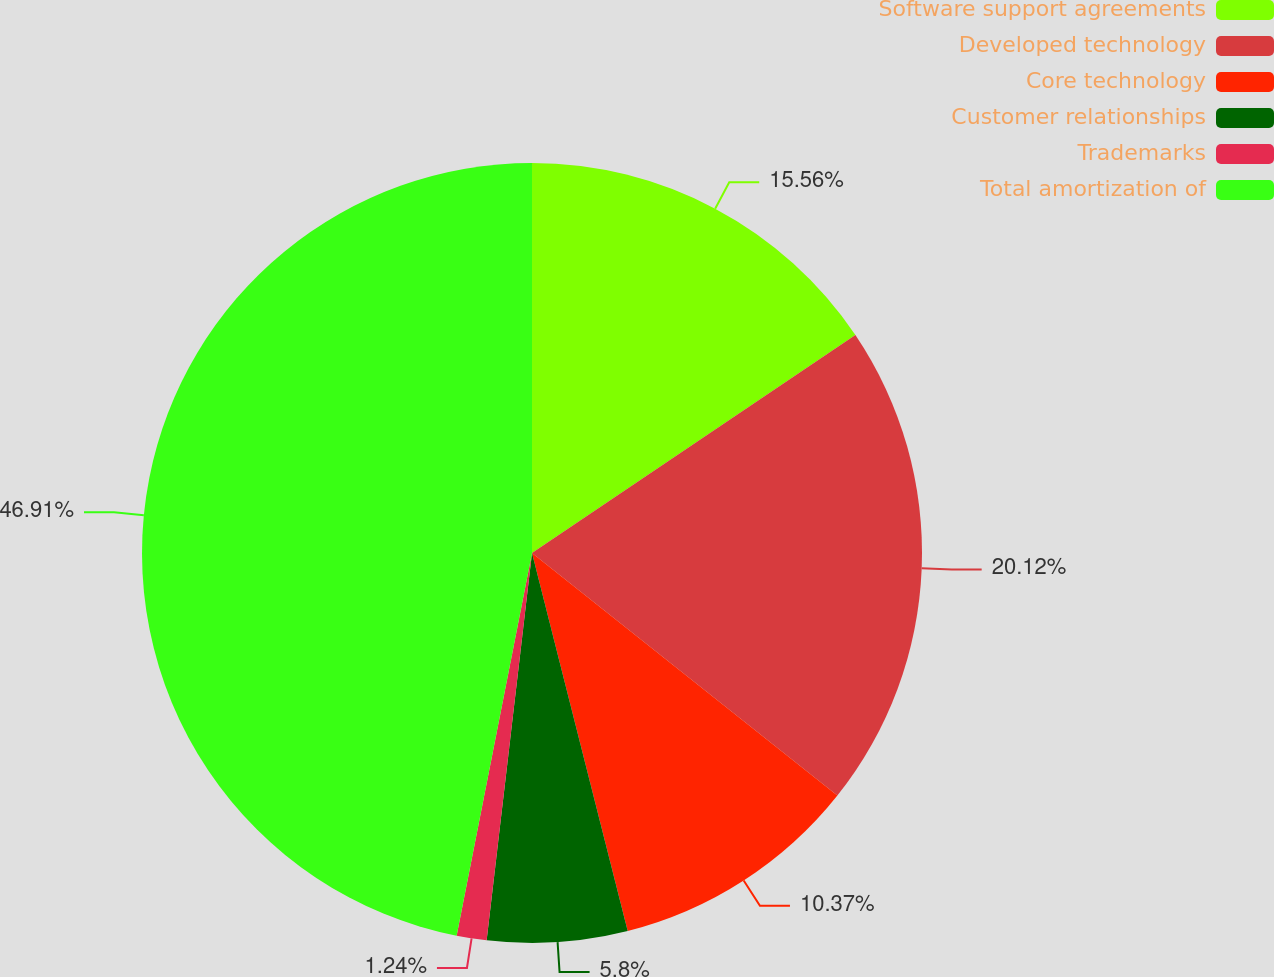Convert chart. <chart><loc_0><loc_0><loc_500><loc_500><pie_chart><fcel>Software support agreements<fcel>Developed technology<fcel>Core technology<fcel>Customer relationships<fcel>Trademarks<fcel>Total amortization of<nl><fcel>15.56%<fcel>20.12%<fcel>10.37%<fcel>5.8%<fcel>1.24%<fcel>46.9%<nl></chart> 